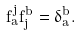Convert formula to latex. <formula><loc_0><loc_0><loc_500><loc_500>f _ { a } ^ { j } f ^ { b } _ { j } = \delta _ { a } ^ { b } .</formula> 